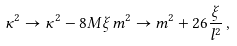Convert formula to latex. <formula><loc_0><loc_0><loc_500><loc_500>\kappa ^ { 2 } \rightarrow \kappa ^ { 2 } - 8 M \xi \, m ^ { 2 } \rightarrow m ^ { 2 } + 2 6 \frac { \xi } { l ^ { 2 } } \, ,</formula> 